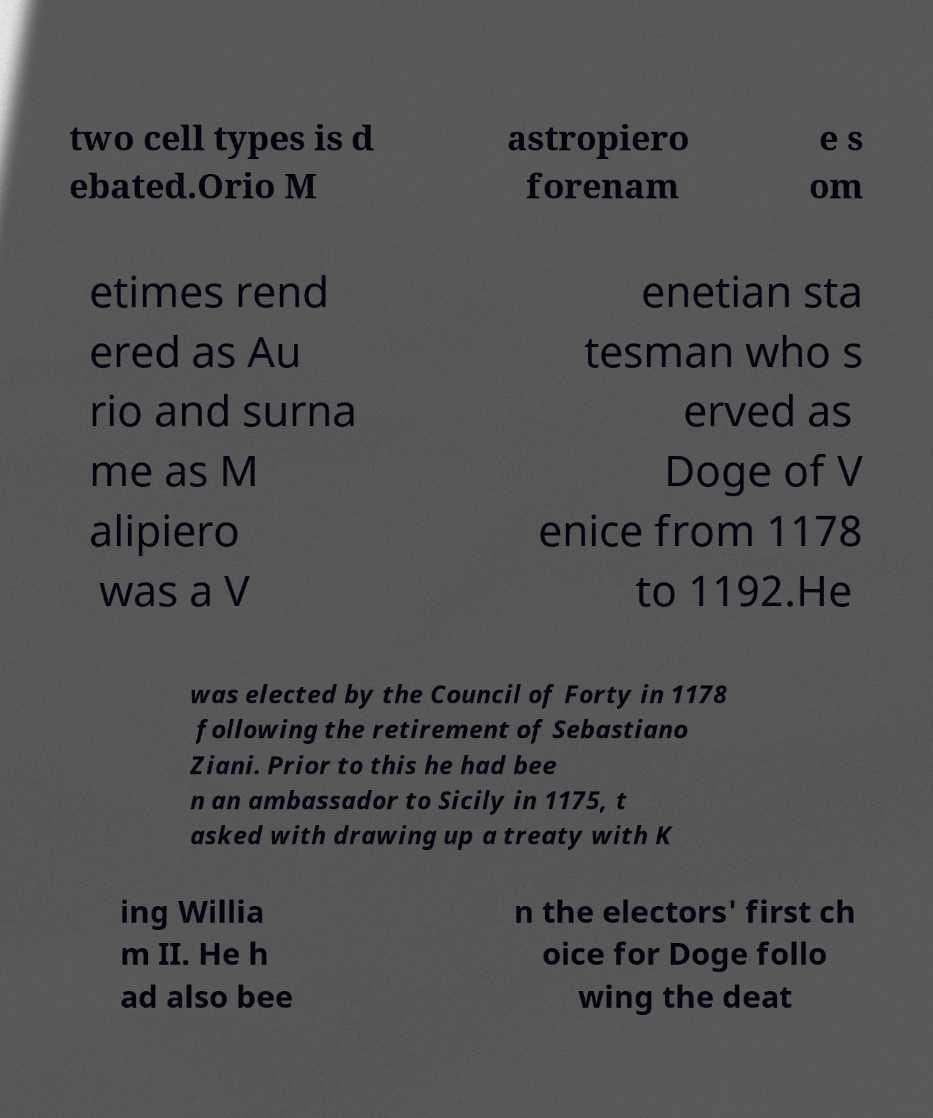I need the written content from this picture converted into text. Can you do that? two cell types is d ebated.Orio M astropiero forenam e s om etimes rend ered as Au rio and surna me as M alipiero was a V enetian sta tesman who s erved as Doge of V enice from 1178 to 1192.He was elected by the Council of Forty in 1178 following the retirement of Sebastiano Ziani. Prior to this he had bee n an ambassador to Sicily in 1175, t asked with drawing up a treaty with K ing Willia m II. He h ad also bee n the electors' first ch oice for Doge follo wing the deat 